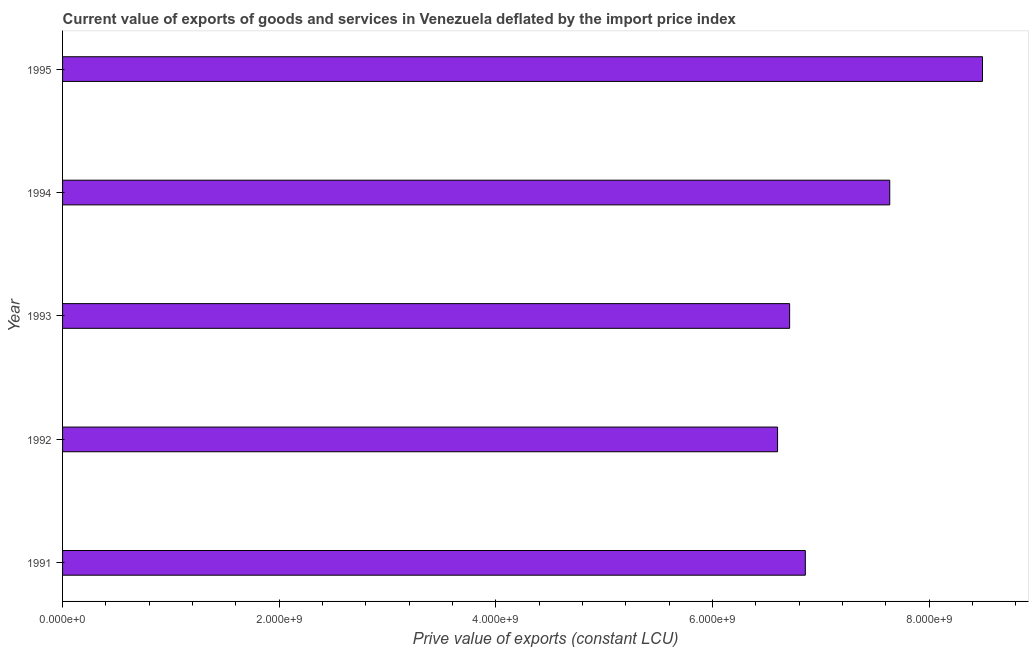Does the graph contain any zero values?
Make the answer very short. No. Does the graph contain grids?
Make the answer very short. No. What is the title of the graph?
Ensure brevity in your answer.  Current value of exports of goods and services in Venezuela deflated by the import price index. What is the label or title of the X-axis?
Offer a terse response. Prive value of exports (constant LCU). What is the label or title of the Y-axis?
Offer a very short reply. Year. What is the price value of exports in 1992?
Offer a terse response. 6.60e+09. Across all years, what is the maximum price value of exports?
Your answer should be compact. 8.49e+09. Across all years, what is the minimum price value of exports?
Offer a very short reply. 6.60e+09. In which year was the price value of exports maximum?
Offer a very short reply. 1995. In which year was the price value of exports minimum?
Your response must be concise. 1992. What is the sum of the price value of exports?
Provide a succinct answer. 3.63e+1. What is the difference between the price value of exports in 1993 and 1994?
Your response must be concise. -9.24e+08. What is the average price value of exports per year?
Your response must be concise. 7.26e+09. What is the median price value of exports?
Ensure brevity in your answer.  6.86e+09. In how many years, is the price value of exports greater than 400000000 LCU?
Provide a succinct answer. 5. Do a majority of the years between 1991 and 1993 (inclusive) have price value of exports greater than 4800000000 LCU?
Keep it short and to the point. Yes. What is the ratio of the price value of exports in 1991 to that in 1993?
Ensure brevity in your answer.  1.02. Is the difference between the price value of exports in 1992 and 1995 greater than the difference between any two years?
Ensure brevity in your answer.  Yes. What is the difference between the highest and the second highest price value of exports?
Offer a very short reply. 8.56e+08. What is the difference between the highest and the lowest price value of exports?
Provide a succinct answer. 1.89e+09. In how many years, is the price value of exports greater than the average price value of exports taken over all years?
Offer a terse response. 2. Are all the bars in the graph horizontal?
Keep it short and to the point. Yes. Are the values on the major ticks of X-axis written in scientific E-notation?
Make the answer very short. Yes. What is the Prive value of exports (constant LCU) of 1991?
Offer a very short reply. 6.86e+09. What is the Prive value of exports (constant LCU) of 1992?
Offer a very short reply. 6.60e+09. What is the Prive value of exports (constant LCU) of 1993?
Your answer should be compact. 6.71e+09. What is the Prive value of exports (constant LCU) of 1994?
Make the answer very short. 7.63e+09. What is the Prive value of exports (constant LCU) of 1995?
Your answer should be compact. 8.49e+09. What is the difference between the Prive value of exports (constant LCU) in 1991 and 1992?
Make the answer very short. 2.56e+08. What is the difference between the Prive value of exports (constant LCU) in 1991 and 1993?
Ensure brevity in your answer.  1.45e+08. What is the difference between the Prive value of exports (constant LCU) in 1991 and 1994?
Make the answer very short. -7.79e+08. What is the difference between the Prive value of exports (constant LCU) in 1991 and 1995?
Give a very brief answer. -1.64e+09. What is the difference between the Prive value of exports (constant LCU) in 1992 and 1993?
Keep it short and to the point. -1.12e+08. What is the difference between the Prive value of exports (constant LCU) in 1992 and 1994?
Keep it short and to the point. -1.04e+09. What is the difference between the Prive value of exports (constant LCU) in 1992 and 1995?
Your answer should be very brief. -1.89e+09. What is the difference between the Prive value of exports (constant LCU) in 1993 and 1994?
Offer a terse response. -9.24e+08. What is the difference between the Prive value of exports (constant LCU) in 1993 and 1995?
Your response must be concise. -1.78e+09. What is the difference between the Prive value of exports (constant LCU) in 1994 and 1995?
Your answer should be very brief. -8.56e+08. What is the ratio of the Prive value of exports (constant LCU) in 1991 to that in 1992?
Offer a terse response. 1.04. What is the ratio of the Prive value of exports (constant LCU) in 1991 to that in 1994?
Provide a succinct answer. 0.9. What is the ratio of the Prive value of exports (constant LCU) in 1991 to that in 1995?
Provide a succinct answer. 0.81. What is the ratio of the Prive value of exports (constant LCU) in 1992 to that in 1993?
Keep it short and to the point. 0.98. What is the ratio of the Prive value of exports (constant LCU) in 1992 to that in 1994?
Give a very brief answer. 0.86. What is the ratio of the Prive value of exports (constant LCU) in 1992 to that in 1995?
Provide a succinct answer. 0.78. What is the ratio of the Prive value of exports (constant LCU) in 1993 to that in 1994?
Make the answer very short. 0.88. What is the ratio of the Prive value of exports (constant LCU) in 1993 to that in 1995?
Provide a succinct answer. 0.79. What is the ratio of the Prive value of exports (constant LCU) in 1994 to that in 1995?
Your response must be concise. 0.9. 